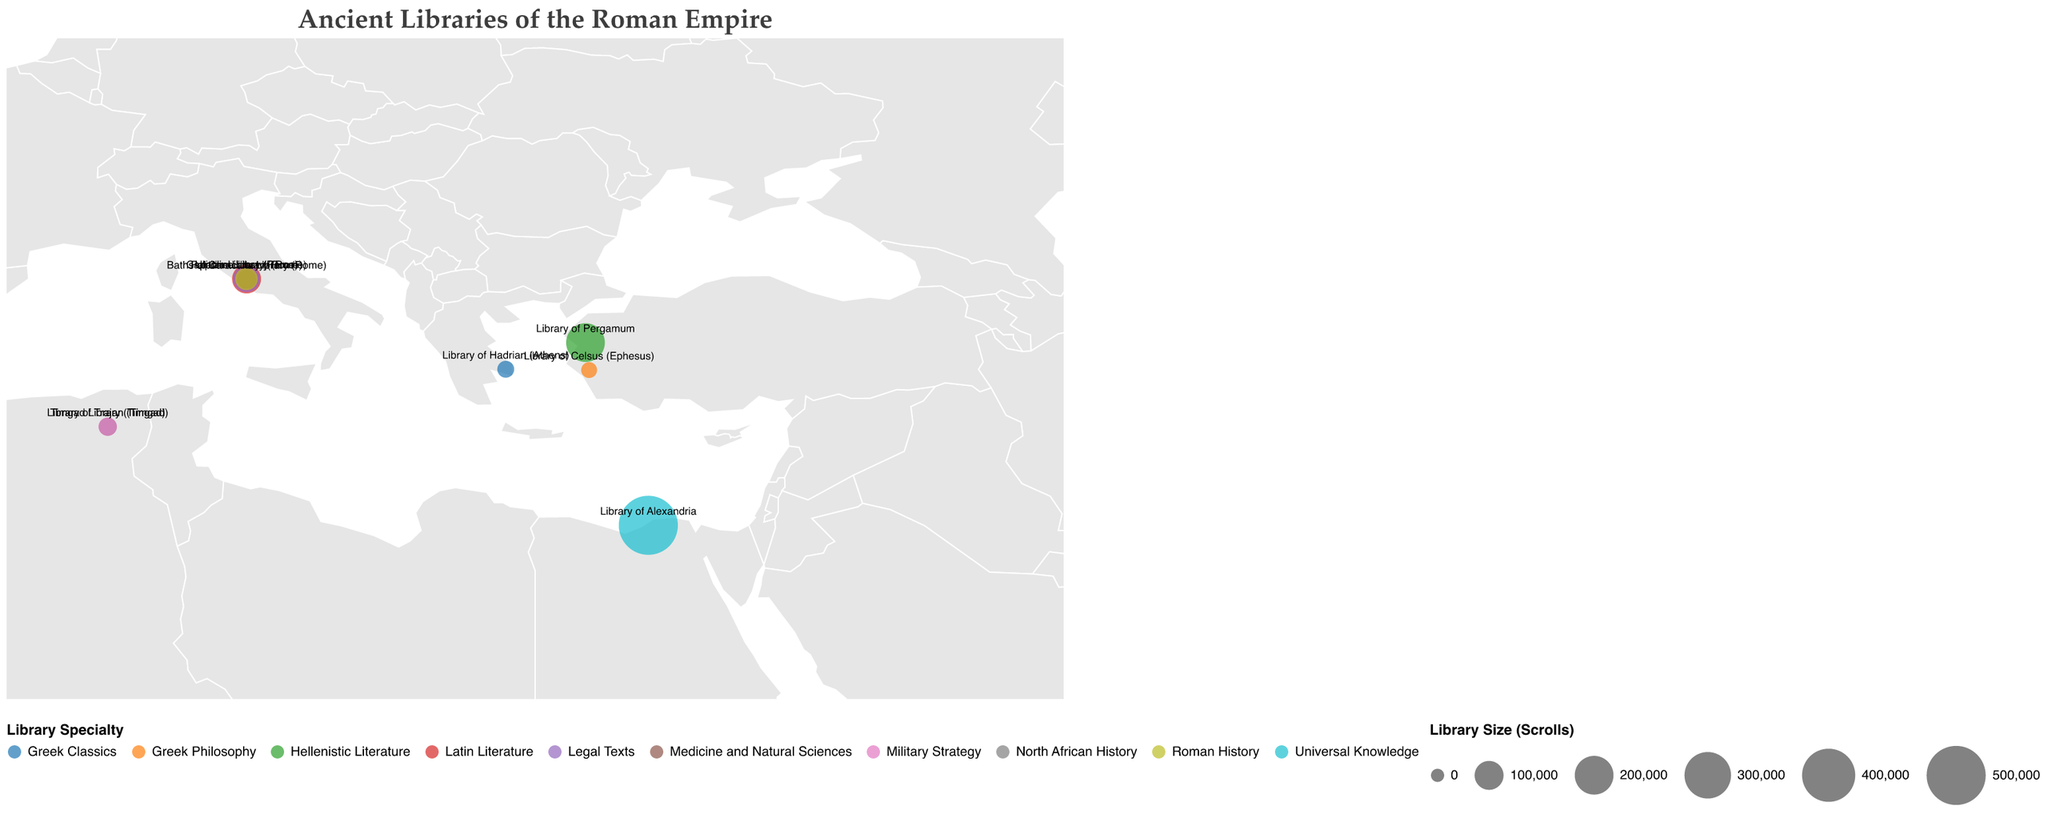What's the title of the figure? The title is displayed at the top of the figure.
Answer: Ancient Libraries of the Roman Empire Which library has the largest number of scrolls? The figure shows circles representing library sizes. The largest circle corresponds to the Library of Alexandria.
Answer: Library of Alexandria What is the specialty of the Library of Celsus? The specialty is displayed in the tooltip when hovering over the Library of Celsus.
Answer: Greek Philosophy How many libraries depicted are located in Rome? Identify the libraries near Rome on the map. Four libraries are located within close proximity.
Answer: Four Which library specializes in 'North African History'? Look for the specialty 'North African History' either in the legend or by hovering over data points. The Timgad Library matches.
Answer: Timgad Library What is the combined number of scrolls in the libraries in Timgad? Sum the scrolls of the Timgad Library and the Library of Trajan located both in Timgad. 23000 + 25000 = 48000
Answer: 48000 How does the size of the Library of Hadrian compare to that of the Baths of Caracalla Library in terms of number of scrolls? Compare the scroll sizes shown on the map. The Library of Hadrian has 17000 scrolls, while the Baths of Caracalla Library has 30000.
Answer: Baths of Caracalla Library is larger Which libraries are located in the Eastern part of the Roman Empire? Identify libraries with longitudes east of the 20-degree line. These libraries include the Library of Alexandria, Library of Pergamum, Library of Celsus, Library of Trajan, and Timgad Library.
Answer: Five What are the coordinates of the Library of Pergamum? The figure shows the Library of Pergamum is located at latitude 39.1315 and longitude 27.1844 when checked.
Answer: 39.1315, 27.1844 Which library has a specialty in 'Military Strategy'? The specialty 'Military Strategy' can be found by hovering over data points. The Library of Trajan matches.
Answer: Library of Trajan 